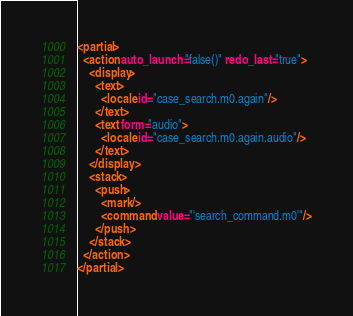Convert code to text. <code><loc_0><loc_0><loc_500><loc_500><_XML_><partial>
  <action auto_launch="false()" redo_last="true">
    <display>
      <text>
        <locale id="case_search.m0.again"/>
      </text>
      <text form="audio">
        <locale id="case_search.m0.again.audio"/>
      </text>
    </display>
    <stack>
      <push>
        <mark/>
        <command value="'search_command.m0'"/>
      </push>
    </stack>
  </action>
</partial>
</code> 